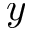<formula> <loc_0><loc_0><loc_500><loc_500>y</formula> 